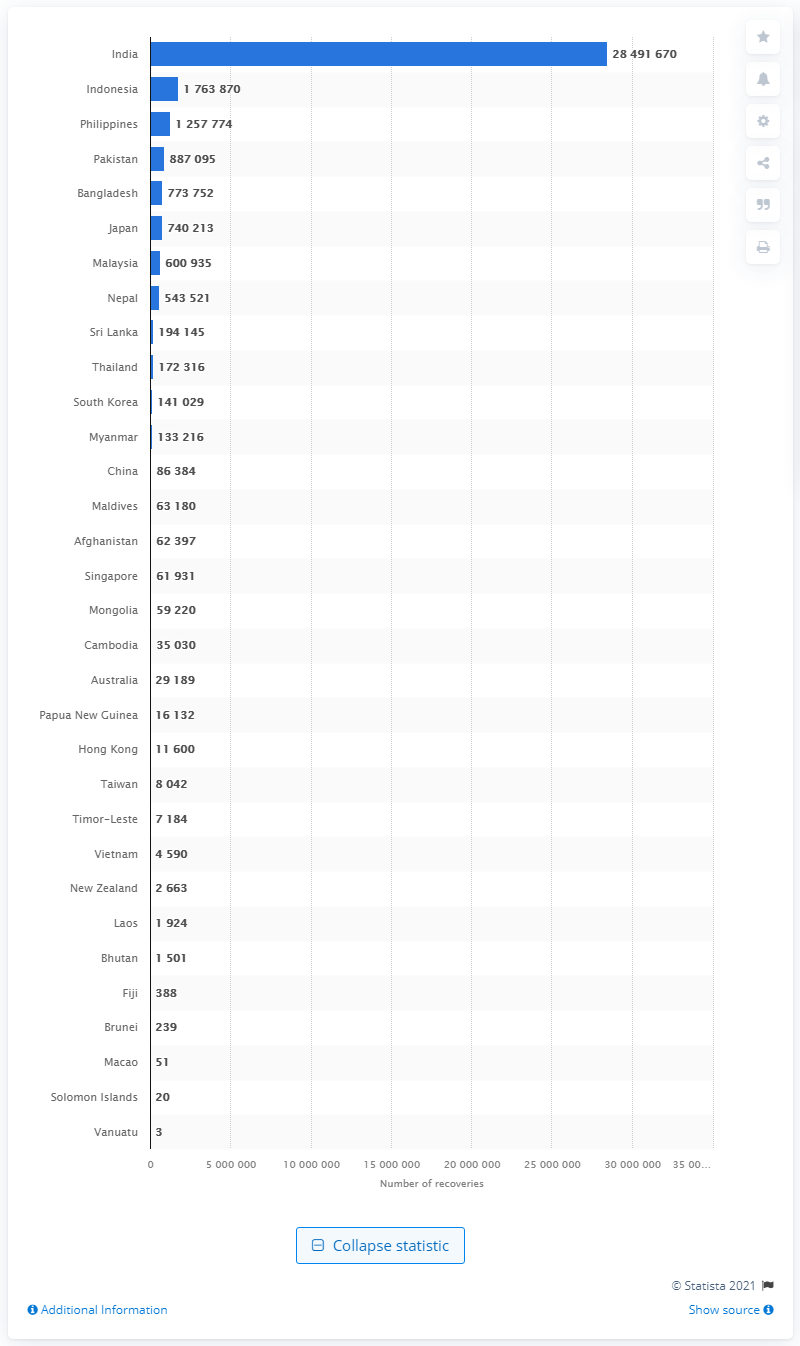Indicate a few pertinent items in this graphic. According to the latest data, Indonesia has recorded the second highest number of COVID-19 recoveries in the Asia Pacific region. As of June 17, 2021, India had reported a total of 284,916,700 coronavirus recoveries. As of June 17, 2021, India had the highest number of coronavirus recoveries in the Asia Pacific region. 